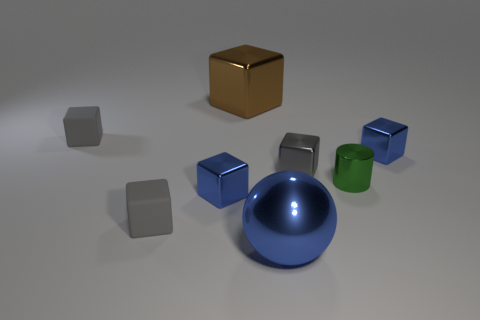There is a large blue object; is it the same shape as the metal object right of the small green shiny cylinder?
Give a very brief answer. No. Are there any big brown shiny objects that are to the right of the small blue object in front of the blue metallic cube on the right side of the green metallic cylinder?
Give a very brief answer. Yes. What size is the green cylinder?
Your response must be concise. Small. What number of other things are there of the same color as the large ball?
Your response must be concise. 2. Is the shape of the tiny gray thing that is on the right side of the big brown metallic block the same as  the large brown thing?
Give a very brief answer. Yes. There is another big object that is the same shape as the gray shiny thing; what is its color?
Give a very brief answer. Brown. The brown metal thing that is the same shape as the tiny gray shiny object is what size?
Your response must be concise. Large. What material is the tiny gray object that is both behind the green cylinder and left of the brown metal cube?
Offer a very short reply. Rubber. Does the tiny matte thing behind the metal cylinder have the same color as the ball?
Provide a short and direct response. No. Does the big metallic cube have the same color as the tiny cube right of the small gray metal object?
Your answer should be compact. No. 